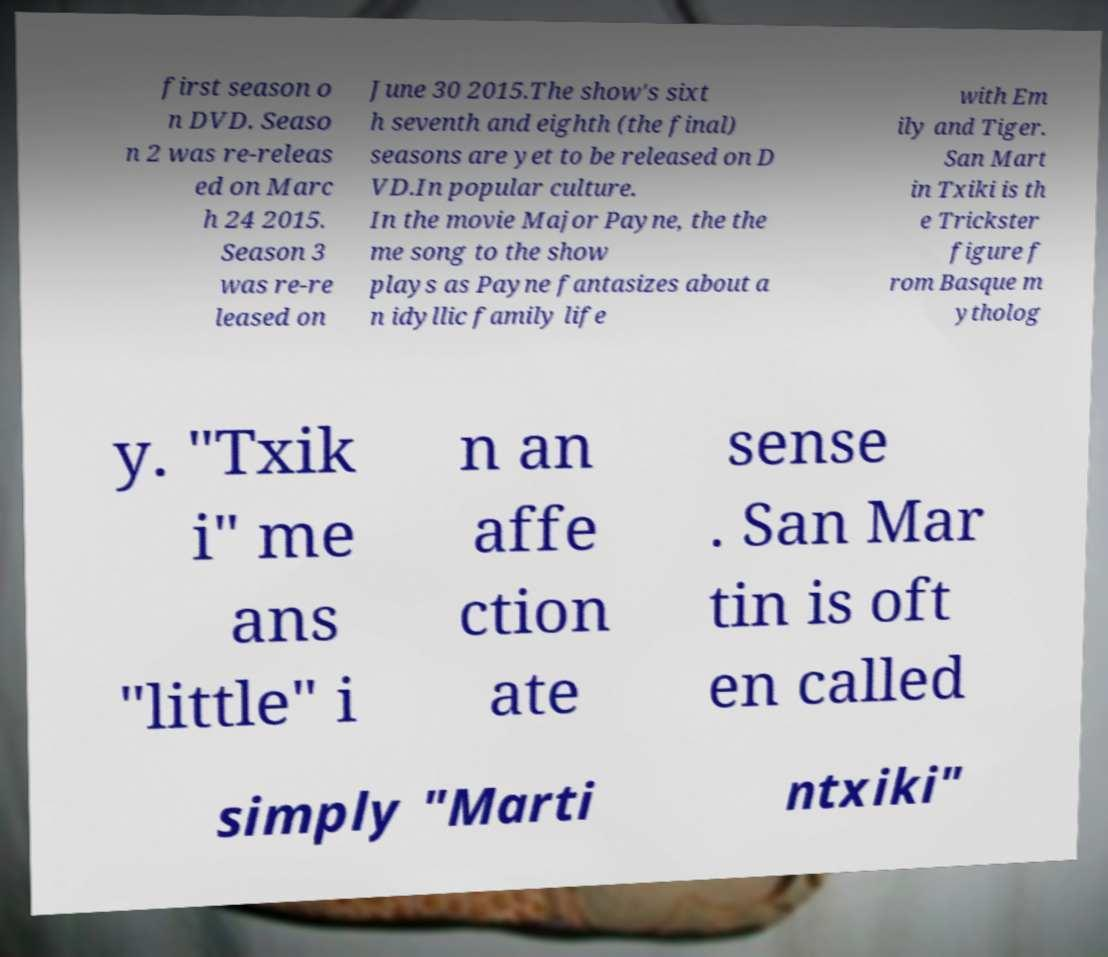Please identify and transcribe the text found in this image. first season o n DVD. Seaso n 2 was re-releas ed on Marc h 24 2015. Season 3 was re-re leased on June 30 2015.The show's sixt h seventh and eighth (the final) seasons are yet to be released on D VD.In popular culture. In the movie Major Payne, the the me song to the show plays as Payne fantasizes about a n idyllic family life with Em ily and Tiger. San Mart in Txiki is th e Trickster figure f rom Basque m ytholog y. "Txik i" me ans "little" i n an affe ction ate sense . San Mar tin is oft en called simply "Marti ntxiki" 